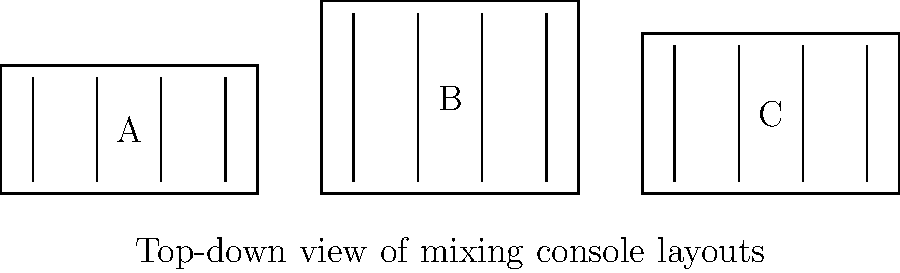In the diagram above, which mixing console layout is most likely to be preferred by a mainstream music producer who values industry standards and proven techniques? To answer this question, we need to consider the characteristics of each layout from the perspective of a mainstream music producer who prioritizes industry norms and tested methods:

1. Layout A: This is a compact, standard layout commonly found in many recording studios. It has a traditional rectangular shape with a consistent depth, which is familiar to most producers and engineers.

2. Layout B: This console has a deeper profile, which could indicate more channels or additional features. While it offers more space, it deviates from the typical compact design favored in many professional studios.

3. Layout C: This layout has a slightly wider and deeper profile than Layout A, but not as deep as Layout B. It represents a middle ground between the other two options.

For a mainstream music producer who believes in sticking to industry norms and tested methods:

- Layout A would be the most familiar and widely used option in professional studios.
- It offers a standard configuration that aligns with traditional mixing techniques.
- The compact design allows for easy reach of all controls, which is crucial for efficient workflow.
- Its widespread use in the industry means it's a proven and reliable setup.

While Layouts B and C might offer some advantages in terms of additional features or space, they deviate from the most common industry standard. A producer focused on tried-and-true methods would likely prefer the most conventional option.

Therefore, Layout A is the most likely choice for a mainstream producer prioritizing industry standards and proven techniques.
Answer: Layout A 